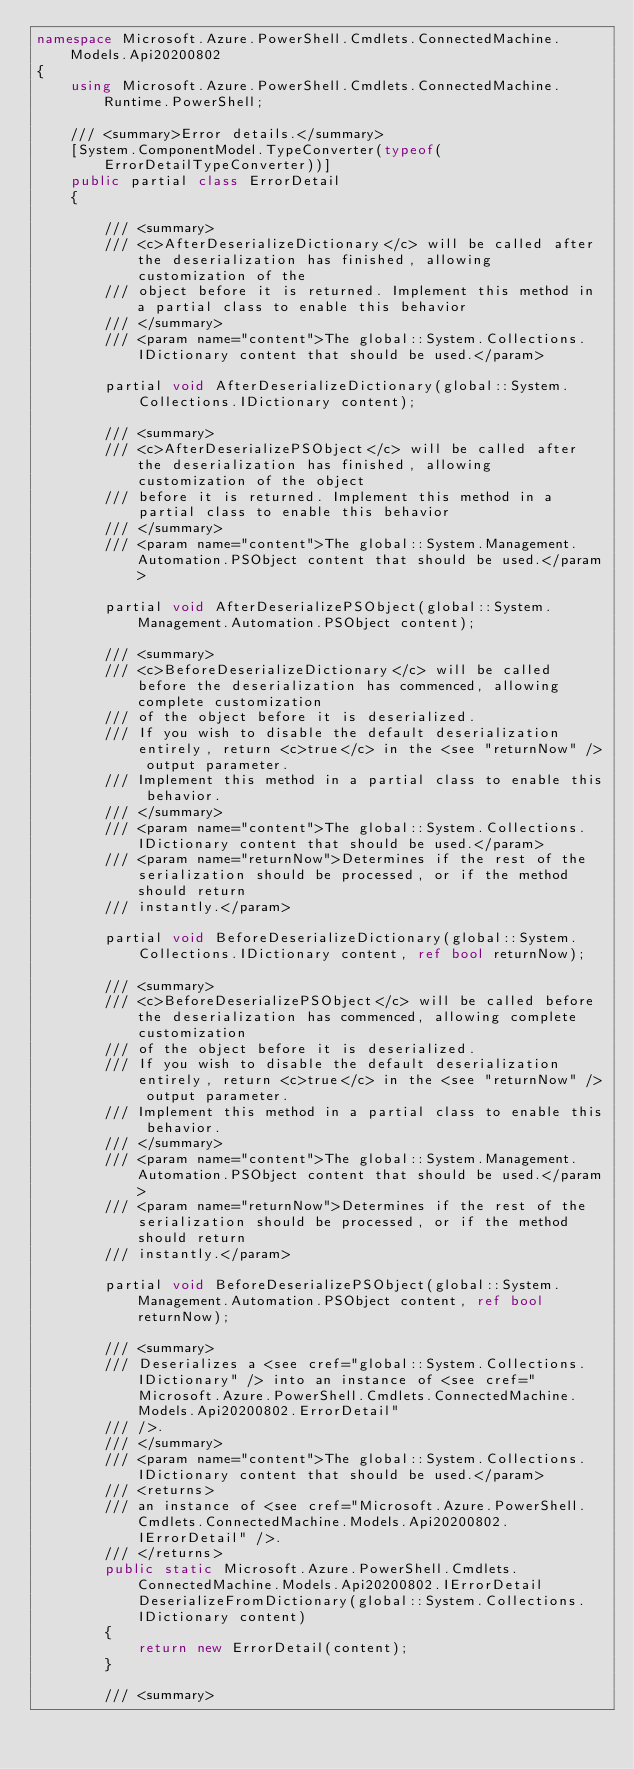Convert code to text. <code><loc_0><loc_0><loc_500><loc_500><_C#_>namespace Microsoft.Azure.PowerShell.Cmdlets.ConnectedMachine.Models.Api20200802
{
    using Microsoft.Azure.PowerShell.Cmdlets.ConnectedMachine.Runtime.PowerShell;

    /// <summary>Error details.</summary>
    [System.ComponentModel.TypeConverter(typeof(ErrorDetailTypeConverter))]
    public partial class ErrorDetail
    {

        /// <summary>
        /// <c>AfterDeserializeDictionary</c> will be called after the deserialization has finished, allowing customization of the
        /// object before it is returned. Implement this method in a partial class to enable this behavior
        /// </summary>
        /// <param name="content">The global::System.Collections.IDictionary content that should be used.</param>

        partial void AfterDeserializeDictionary(global::System.Collections.IDictionary content);

        /// <summary>
        /// <c>AfterDeserializePSObject</c> will be called after the deserialization has finished, allowing customization of the object
        /// before it is returned. Implement this method in a partial class to enable this behavior
        /// </summary>
        /// <param name="content">The global::System.Management.Automation.PSObject content that should be used.</param>

        partial void AfterDeserializePSObject(global::System.Management.Automation.PSObject content);

        /// <summary>
        /// <c>BeforeDeserializeDictionary</c> will be called before the deserialization has commenced, allowing complete customization
        /// of the object before it is deserialized.
        /// If you wish to disable the default deserialization entirely, return <c>true</c> in the <see "returnNow" /> output parameter.
        /// Implement this method in a partial class to enable this behavior.
        /// </summary>
        /// <param name="content">The global::System.Collections.IDictionary content that should be used.</param>
        /// <param name="returnNow">Determines if the rest of the serialization should be processed, or if the method should return
        /// instantly.</param>

        partial void BeforeDeserializeDictionary(global::System.Collections.IDictionary content, ref bool returnNow);

        /// <summary>
        /// <c>BeforeDeserializePSObject</c> will be called before the deserialization has commenced, allowing complete customization
        /// of the object before it is deserialized.
        /// If you wish to disable the default deserialization entirely, return <c>true</c> in the <see "returnNow" /> output parameter.
        /// Implement this method in a partial class to enable this behavior.
        /// </summary>
        /// <param name="content">The global::System.Management.Automation.PSObject content that should be used.</param>
        /// <param name="returnNow">Determines if the rest of the serialization should be processed, or if the method should return
        /// instantly.</param>

        partial void BeforeDeserializePSObject(global::System.Management.Automation.PSObject content, ref bool returnNow);

        /// <summary>
        /// Deserializes a <see cref="global::System.Collections.IDictionary" /> into an instance of <see cref="Microsoft.Azure.PowerShell.Cmdlets.ConnectedMachine.Models.Api20200802.ErrorDetail"
        /// />.
        /// </summary>
        /// <param name="content">The global::System.Collections.IDictionary content that should be used.</param>
        /// <returns>
        /// an instance of <see cref="Microsoft.Azure.PowerShell.Cmdlets.ConnectedMachine.Models.Api20200802.IErrorDetail" />.
        /// </returns>
        public static Microsoft.Azure.PowerShell.Cmdlets.ConnectedMachine.Models.Api20200802.IErrorDetail DeserializeFromDictionary(global::System.Collections.IDictionary content)
        {
            return new ErrorDetail(content);
        }

        /// <summary></code> 